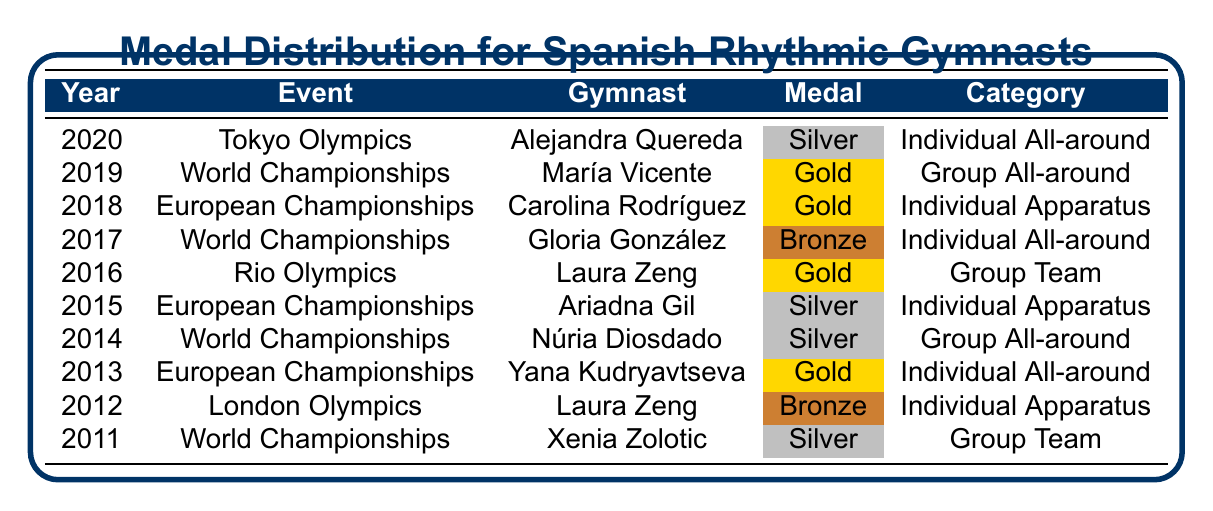What medal did Alejandra Quereda win at the Tokyo Olympics? The table shows that Alejandra Quereda won a Silver medal at the Tokyo Olympics in 2020.
Answer: Silver Which gymnast won a Gold medal in Group All-around? According to the table, María Vicente won a Gold medal in Group All-around at the World Championships in 2019.
Answer: María Vicente How many Silver medals were won by Spanish rhythmic gymnasts in the year 2014 or later? The table lists Silver medals for Alejandra Quereda (2020), Ariadna Gil (2015), and Núria Diosdado (2014). Thus, there are three Silver medals won in that timeframe.
Answer: 3 Was there a Gold medal winner in Individual Apparatus from Spain? The table shows that Carolina Rodríguez won a Gold medal in Individual Apparatus at the European Championships in 2018. Therefore, the statement is true.
Answer: Yes In which event did Laura Zeng win her Gold medal? Laura Zeng won a Gold medal in Group Team at the Rio Olympics in 2016, as per the table data.
Answer: Rio Olympics If we total the medals won by Spanish rhythmic gymnasts, how many Gold medals can we find? The table lists Gold medals for three gymnasts: María Vicente (2019), Carolina Rodríguez (2018), and Laura Zeng (2016). Adding these gives a total of three Gold medals.
Answer: 3 Who won a medal in the year 2012, and what was it? The table indicates that Laura Zeng won a Bronze medal in 2012 at the London Olympics.
Answer: Laura Zeng, Bronze How has the trend of winning Gold medals changed from the years 2011 to 2020? Based on the table, there were no Gold medals in 2011, but three were won in 2016, 2018, and 2019, indicating an upward trend in Gold medal acquisition over those years.
Answer: Increased What was the most recent event listed in the table, and what medal was won? The most recent event in the table is the Tokyo Olympics in 2020, where Alejandra Quereda won a Silver medal.
Answer: Tokyo Olympics, Silver How many different gymnasts won medals in 2019? The table shows one gymnast, María Vicente, who won a Gold medal in 2019. Therefore, the answer is one gymnast.
Answer: 1 